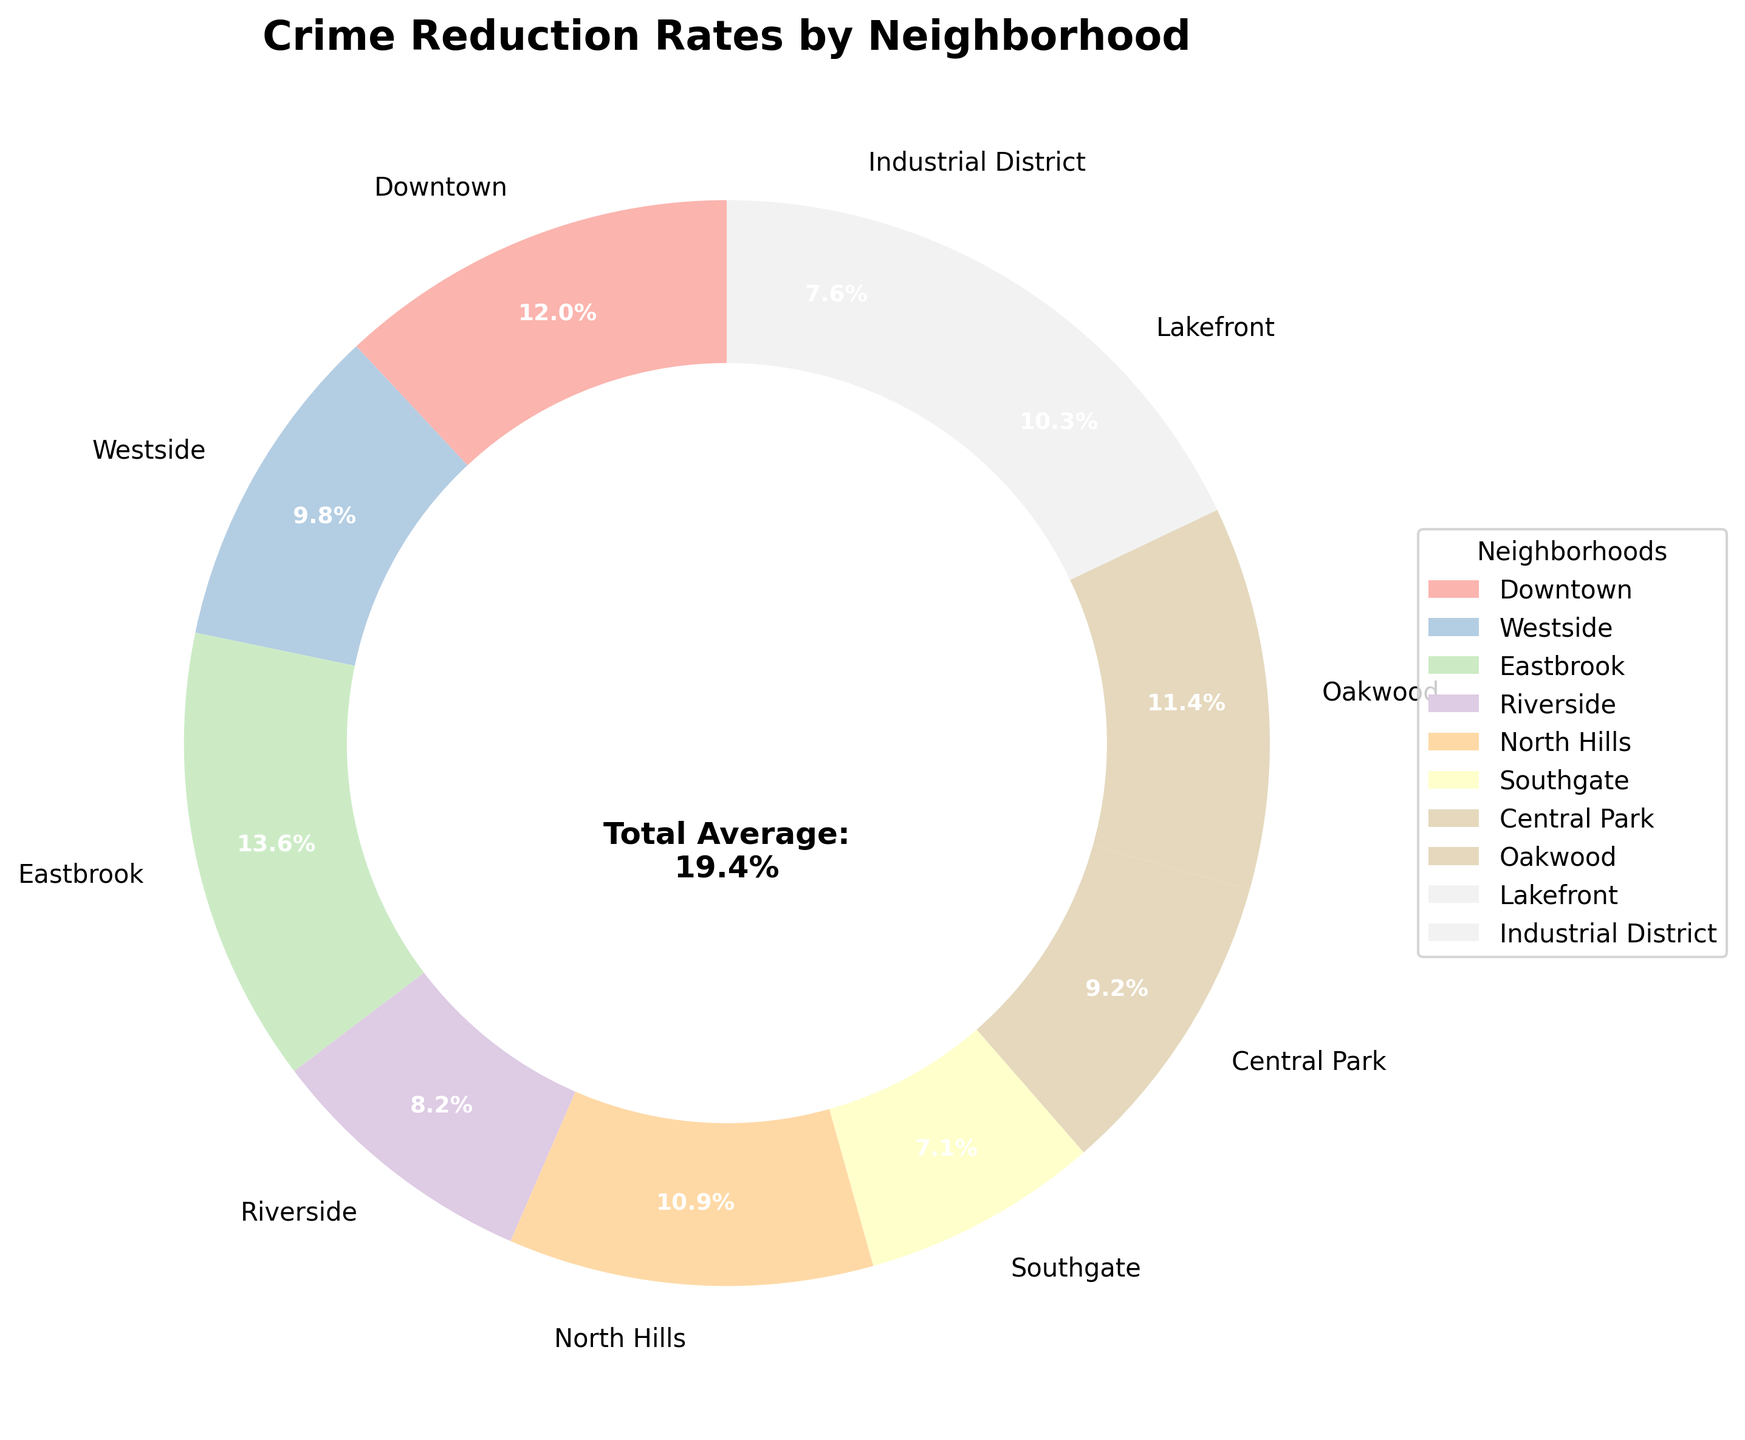Which neighborhood has the highest crime reduction rate? First, identify the neighborhood with the highest percentage on the pie chart. Eastbrook has the highest crime reduction rate at 25%.
Answer: Eastbrook Which neighborhood has the lowest crime reduction rate? Look for the neighborhood with the smallest percentage on the pie chart. Southgate has the lowest crime reduction rate at 13%.
Answer: Southgate How much higher is Eastbrook's crime reduction rate compared to Riverside's? Eastbrook's rate is 25% and Riverside's is 15%. The difference is calculated by subtracting 15 from 25, resulting in 10%.
Answer: 10% What is the total percentage of crime reduction in Downtown, North Hills, and Oakwood? Adding Downtown (22%), North Hills (20%), and Oakwood (21%) gives 22 + 20 + 21 = 63%.
Answer: 63% Is the crime reduction rate of Central Park higher or lower than that of Lakefront? Compare Central Park's rate (17%) with Lakefront's rate (19%). Central Park's rate is lower.
Answer: Lower Which two neighborhoods have the most similar crime reduction rates? Compare the percentages visually or numerically. Downtown (22%) and Oakwood (21%) have the most similar rates, with only a 1% difference.
Answer: Downtown and Oakwood Are there more neighborhoods with a crime reduction rate above 20% or below 20%? Count the neighborhoods with rates above 20% (Downtown, Eastbrook, Oakwood) and those below 20% (Westside, Riverside, North Hills, Southgate, Central Park, Lakefront, Industrial District). There are 3 neighborhoods above 20% and 7 below.
Answer: Below 20% What is the average crime reduction rate if you exclude Eastbrook? Excluding Eastbrook’s 25%, sum the remaining rates (22+18+15+20+13+17+21+19+14 = 159) and divide by 9 neighborhoods. The average is 159 / 9 ≈ 17.7%.
Answer: 17.7% How does the crime reduction rate of North Hills compare to the total average rate shown in the center? North Hills has a 20% reduction rate, which is slightly above the total average of 19.4% as shown in the center annotation.
Answer: Above Which neighborhoods have a crime reduction rate within 2% of the total average? The total average is 19.4%. Neighborhoods within 2% would have rates between 17.4% and 21.4%. These neighborhoods are North Hills (20%), Oakwood (21%), Lakefront (19%), and Central Park (17%).
Answer: North Hills, Oakwood, Lakefront, Central Park 